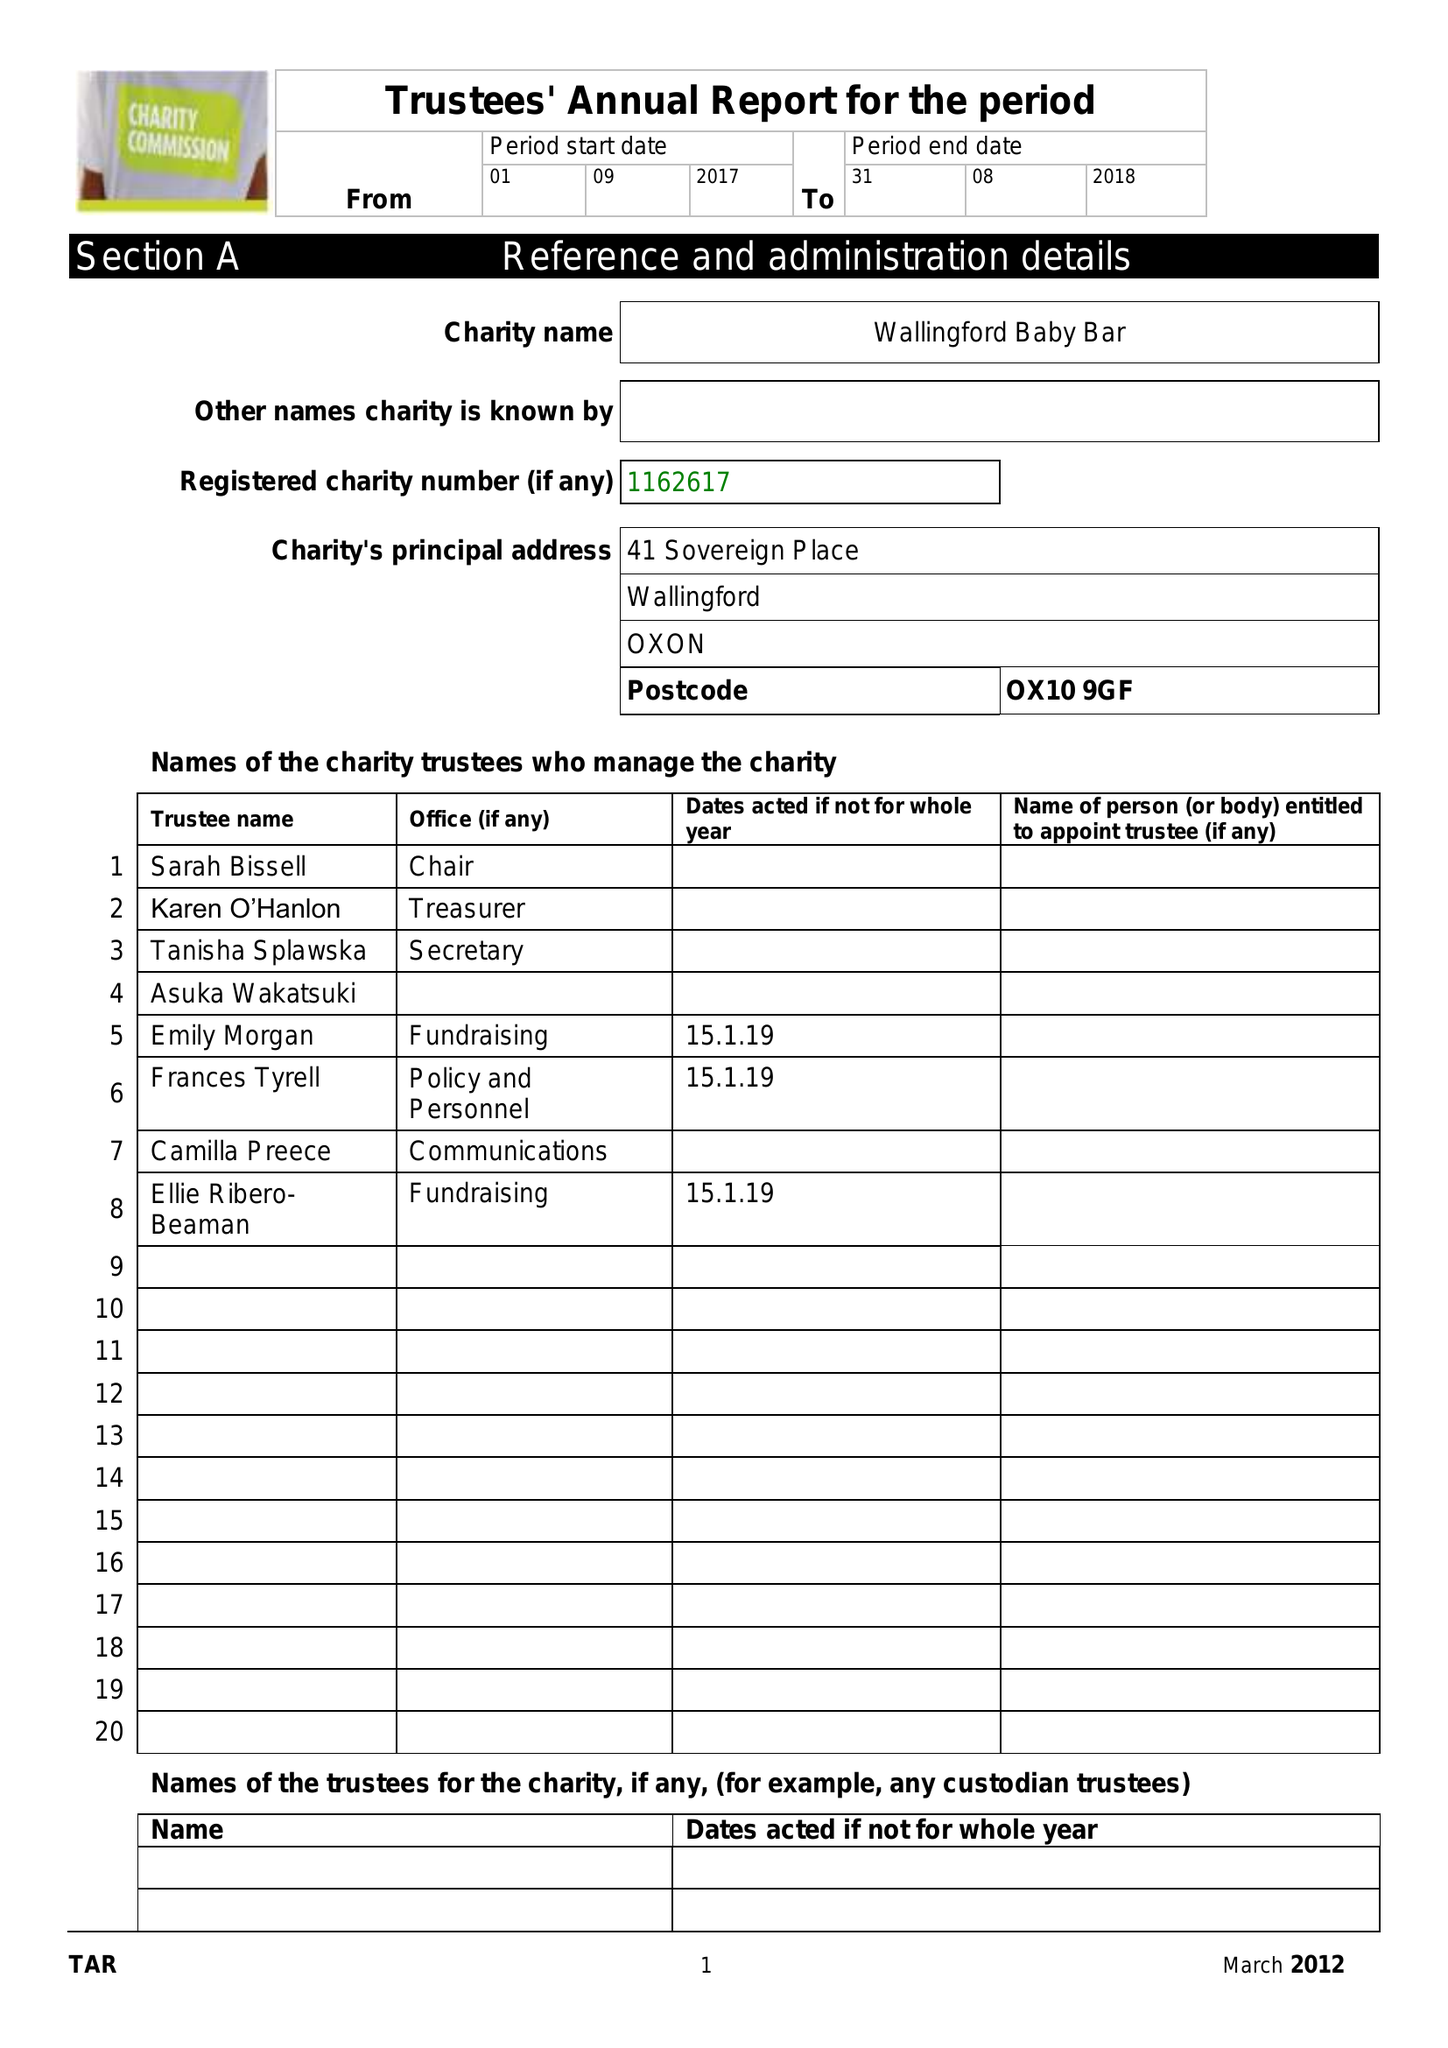What is the value for the address__postcode?
Answer the question using a single word or phrase. OX10 9GF 